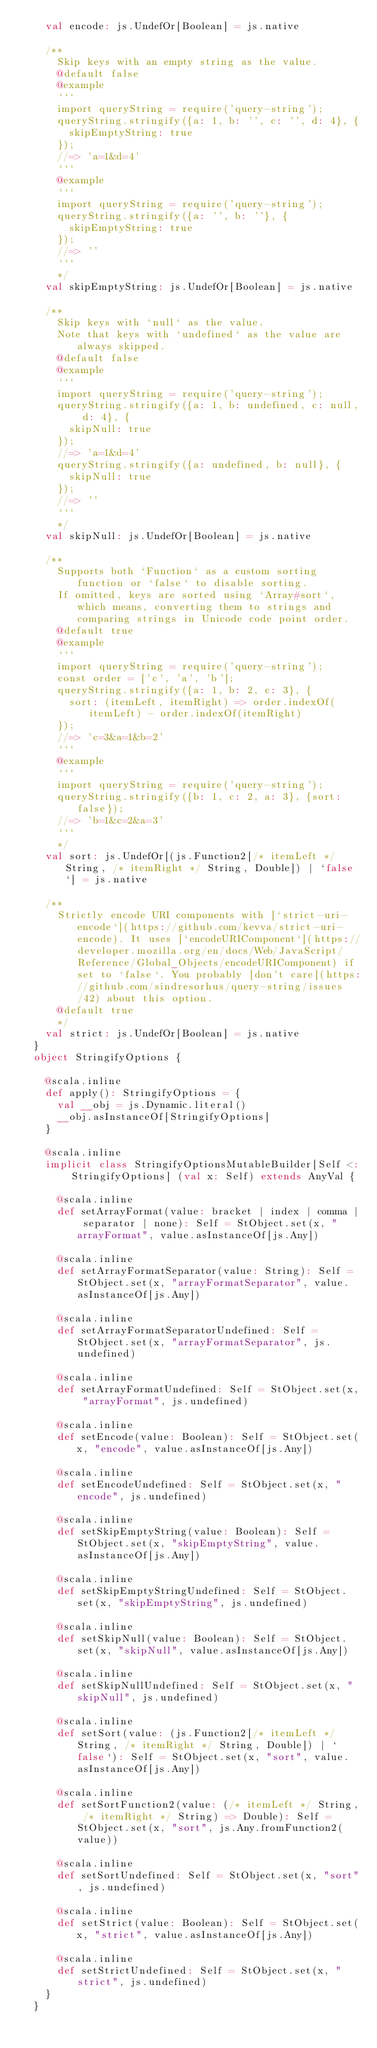<code> <loc_0><loc_0><loc_500><loc_500><_Scala_>    val encode: js.UndefOr[Boolean] = js.native
    
    /**
    	Skip keys with an empty string as the value.
    	@default false
    	@example
    	```
    	import queryString = require('query-string');
    	queryString.stringify({a: 1, b: '', c: '', d: 4}, {
    		skipEmptyString: true
    	});
    	//=> 'a=1&d=4'
    	```
    	@example
    	```
    	import queryString = require('query-string');
    	queryString.stringify({a: '', b: ''}, {
    		skipEmptyString: true
    	});
    	//=> ''
    	```
    	*/
    val skipEmptyString: js.UndefOr[Boolean] = js.native
    
    /**
    	Skip keys with `null` as the value.
    	Note that keys with `undefined` as the value are always skipped.
    	@default false
    	@example
    	```
    	import queryString = require('query-string');
    	queryString.stringify({a: 1, b: undefined, c: null, d: 4}, {
    		skipNull: true
    	});
    	//=> 'a=1&d=4'
    	queryString.stringify({a: undefined, b: null}, {
    		skipNull: true
    	});
    	//=> ''
    	```
    	*/
    val skipNull: js.UndefOr[Boolean] = js.native
    
    /**
    	Supports both `Function` as a custom sorting function or `false` to disable sorting.
    	If omitted, keys are sorted using `Array#sort`, which means, converting them to strings and comparing strings in Unicode code point order.
    	@default true
    	@example
    	```
    	import queryString = require('query-string');
    	const order = ['c', 'a', 'b'];
    	queryString.stringify({a: 1, b: 2, c: 3}, {
    		sort: (itemLeft, itemRight) => order.indexOf(itemLeft) - order.indexOf(itemRight)
    	});
    	//=> 'c=3&a=1&b=2'
    	```
    	@example
    	```
    	import queryString = require('query-string');
    	queryString.stringify({b: 1, c: 2, a: 3}, {sort: false});
    	//=> 'b=1&c=2&a=3'
    	```
    	*/
    val sort: js.UndefOr[(js.Function2[/* itemLeft */ String, /* itemRight */ String, Double]) | `false`] = js.native
    
    /**
    	Strictly encode URI components with [`strict-uri-encode`](https://github.com/kevva/strict-uri-encode). It uses [`encodeURIComponent`](https://developer.mozilla.org/en/docs/Web/JavaScript/Reference/Global_Objects/encodeURIComponent) if set to `false`. You probably [don't care](https://github.com/sindresorhus/query-string/issues/42) about this option.
    	@default true
    	*/
    val strict: js.UndefOr[Boolean] = js.native
  }
  object StringifyOptions {
    
    @scala.inline
    def apply(): StringifyOptions = {
      val __obj = js.Dynamic.literal()
      __obj.asInstanceOf[StringifyOptions]
    }
    
    @scala.inline
    implicit class StringifyOptionsMutableBuilder[Self <: StringifyOptions] (val x: Self) extends AnyVal {
      
      @scala.inline
      def setArrayFormat(value: bracket | index | comma | separator | none): Self = StObject.set(x, "arrayFormat", value.asInstanceOf[js.Any])
      
      @scala.inline
      def setArrayFormatSeparator(value: String): Self = StObject.set(x, "arrayFormatSeparator", value.asInstanceOf[js.Any])
      
      @scala.inline
      def setArrayFormatSeparatorUndefined: Self = StObject.set(x, "arrayFormatSeparator", js.undefined)
      
      @scala.inline
      def setArrayFormatUndefined: Self = StObject.set(x, "arrayFormat", js.undefined)
      
      @scala.inline
      def setEncode(value: Boolean): Self = StObject.set(x, "encode", value.asInstanceOf[js.Any])
      
      @scala.inline
      def setEncodeUndefined: Self = StObject.set(x, "encode", js.undefined)
      
      @scala.inline
      def setSkipEmptyString(value: Boolean): Self = StObject.set(x, "skipEmptyString", value.asInstanceOf[js.Any])
      
      @scala.inline
      def setSkipEmptyStringUndefined: Self = StObject.set(x, "skipEmptyString", js.undefined)
      
      @scala.inline
      def setSkipNull(value: Boolean): Self = StObject.set(x, "skipNull", value.asInstanceOf[js.Any])
      
      @scala.inline
      def setSkipNullUndefined: Self = StObject.set(x, "skipNull", js.undefined)
      
      @scala.inline
      def setSort(value: (js.Function2[/* itemLeft */ String, /* itemRight */ String, Double]) | `false`): Self = StObject.set(x, "sort", value.asInstanceOf[js.Any])
      
      @scala.inline
      def setSortFunction2(value: (/* itemLeft */ String, /* itemRight */ String) => Double): Self = StObject.set(x, "sort", js.Any.fromFunction2(value))
      
      @scala.inline
      def setSortUndefined: Self = StObject.set(x, "sort", js.undefined)
      
      @scala.inline
      def setStrict(value: Boolean): Self = StObject.set(x, "strict", value.asInstanceOf[js.Any])
      
      @scala.inline
      def setStrictUndefined: Self = StObject.set(x, "strict", js.undefined)
    }
  }
  </code> 